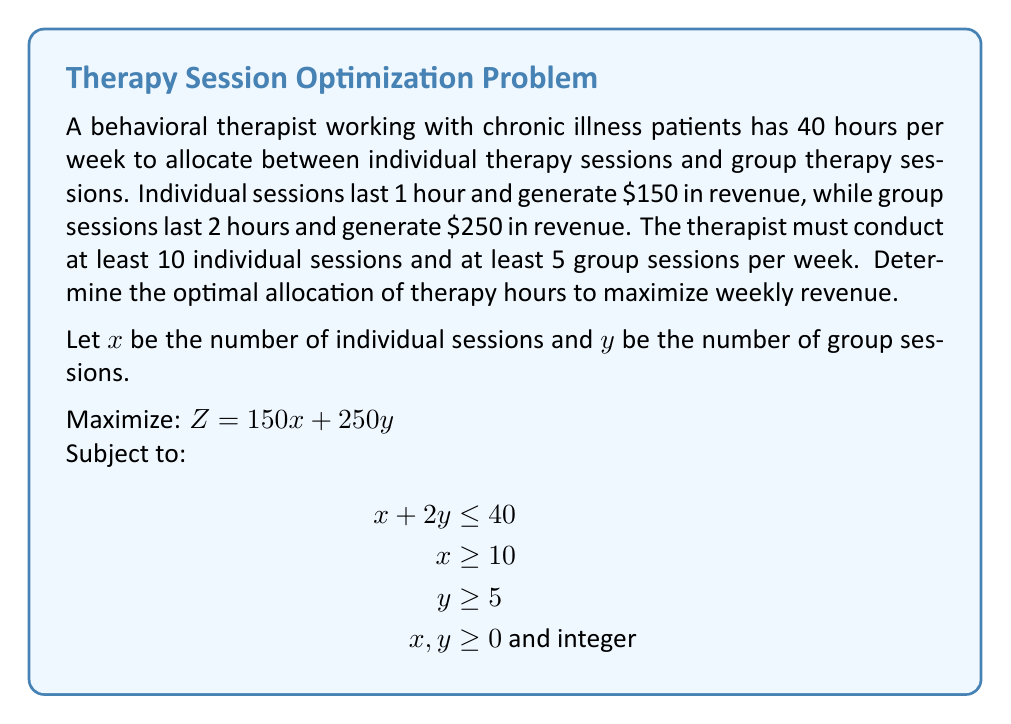Solve this math problem. To solve this linear programming problem, we'll use the graphical method:

1. Plot the constraints:
   a. $x + 2y = 40$ (time constraint)
   b. $x = 10$ (minimum individual sessions)
   c. $y = 5$ (minimum group sessions)

2. Identify the feasible region:
   The feasible region is the area that satisfies all constraints.

3. Find the corner points of the feasible region:
   A: (10, 15)
   B: (30, 5)

4. Evaluate the objective function at each corner point:
   A: $Z = 150(10) + 250(15) = 5250$
   B: $Z = 150(30) + 250(5) = 5750$

5. Choose the point that maximizes the objective function:
   Point B (30, 5) yields the maximum revenue of $5750.

Therefore, the optimal allocation is 30 individual sessions and 5 group sessions per week.
Answer: 30 individual sessions, 5 group sessions; $5750 weekly revenue 